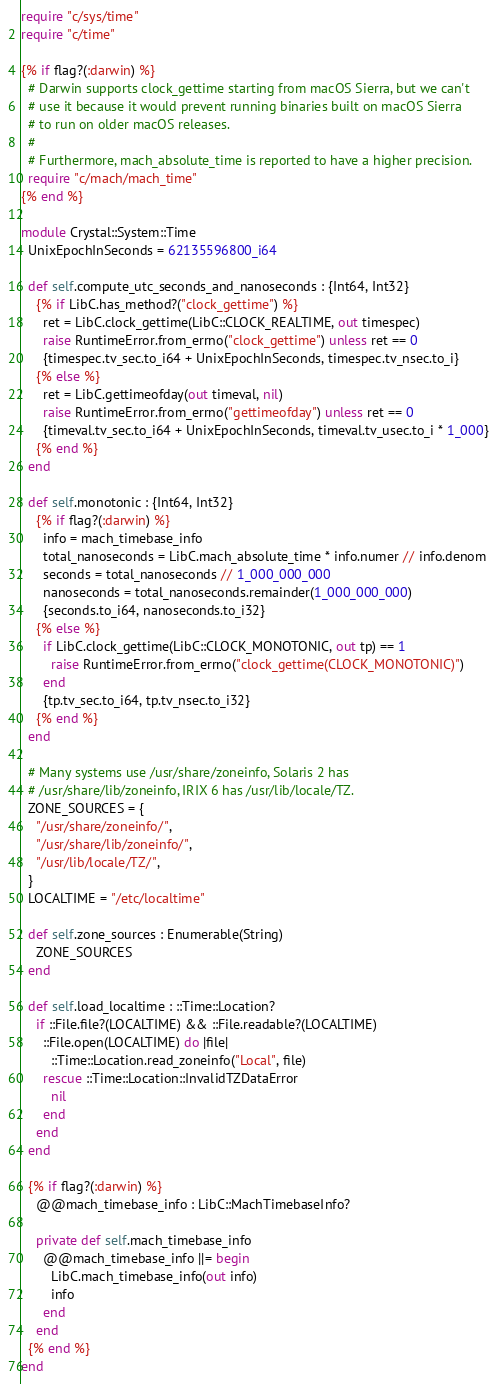<code> <loc_0><loc_0><loc_500><loc_500><_Crystal_>require "c/sys/time"
require "c/time"

{% if flag?(:darwin) %}
  # Darwin supports clock_gettime starting from macOS Sierra, but we can't
  # use it because it would prevent running binaries built on macOS Sierra
  # to run on older macOS releases.
  #
  # Furthermore, mach_absolute_time is reported to have a higher precision.
  require "c/mach/mach_time"
{% end %}

module Crystal::System::Time
  UnixEpochInSeconds = 62135596800_i64

  def self.compute_utc_seconds_and_nanoseconds : {Int64, Int32}
    {% if LibC.has_method?("clock_gettime") %}
      ret = LibC.clock_gettime(LibC::CLOCK_REALTIME, out timespec)
      raise RuntimeError.from_errno("clock_gettime") unless ret == 0
      {timespec.tv_sec.to_i64 + UnixEpochInSeconds, timespec.tv_nsec.to_i}
    {% else %}
      ret = LibC.gettimeofday(out timeval, nil)
      raise RuntimeError.from_errno("gettimeofday") unless ret == 0
      {timeval.tv_sec.to_i64 + UnixEpochInSeconds, timeval.tv_usec.to_i * 1_000}
    {% end %}
  end

  def self.monotonic : {Int64, Int32}
    {% if flag?(:darwin) %}
      info = mach_timebase_info
      total_nanoseconds = LibC.mach_absolute_time * info.numer // info.denom
      seconds = total_nanoseconds // 1_000_000_000
      nanoseconds = total_nanoseconds.remainder(1_000_000_000)
      {seconds.to_i64, nanoseconds.to_i32}
    {% else %}
      if LibC.clock_gettime(LibC::CLOCK_MONOTONIC, out tp) == 1
        raise RuntimeError.from_errno("clock_gettime(CLOCK_MONOTONIC)")
      end
      {tp.tv_sec.to_i64, tp.tv_nsec.to_i32}
    {% end %}
  end

  # Many systems use /usr/share/zoneinfo, Solaris 2 has
  # /usr/share/lib/zoneinfo, IRIX 6 has /usr/lib/locale/TZ.
  ZONE_SOURCES = {
    "/usr/share/zoneinfo/",
    "/usr/share/lib/zoneinfo/",
    "/usr/lib/locale/TZ/",
  }
  LOCALTIME = "/etc/localtime"

  def self.zone_sources : Enumerable(String)
    ZONE_SOURCES
  end

  def self.load_localtime : ::Time::Location?
    if ::File.file?(LOCALTIME) && ::File.readable?(LOCALTIME)
      ::File.open(LOCALTIME) do |file|
        ::Time::Location.read_zoneinfo("Local", file)
      rescue ::Time::Location::InvalidTZDataError
        nil
      end
    end
  end

  {% if flag?(:darwin) %}
    @@mach_timebase_info : LibC::MachTimebaseInfo?

    private def self.mach_timebase_info
      @@mach_timebase_info ||= begin
        LibC.mach_timebase_info(out info)
        info
      end
    end
  {% end %}
end
</code> 